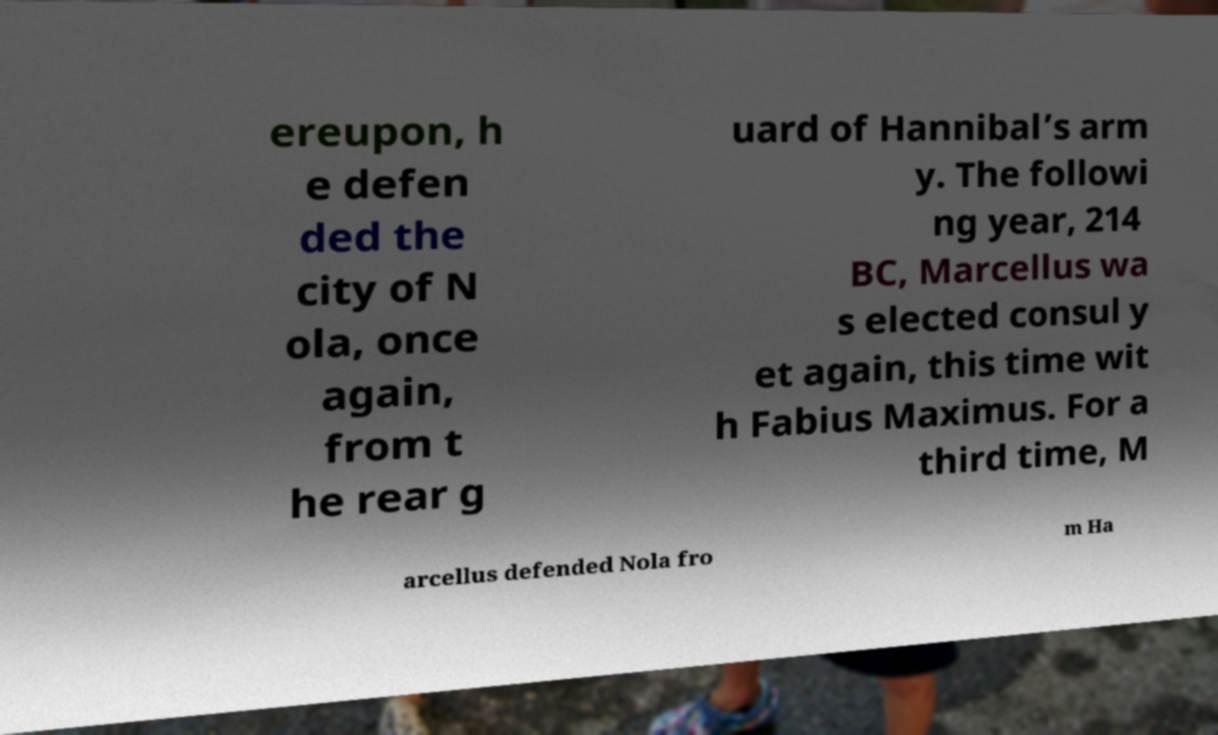What messages or text are displayed in this image? I need them in a readable, typed format. ereupon, h e defen ded the city of N ola, once again, from t he rear g uard of Hannibal’s arm y. The followi ng year, 214 BC, Marcellus wa s elected consul y et again, this time wit h Fabius Maximus. For a third time, M arcellus defended Nola fro m Ha 